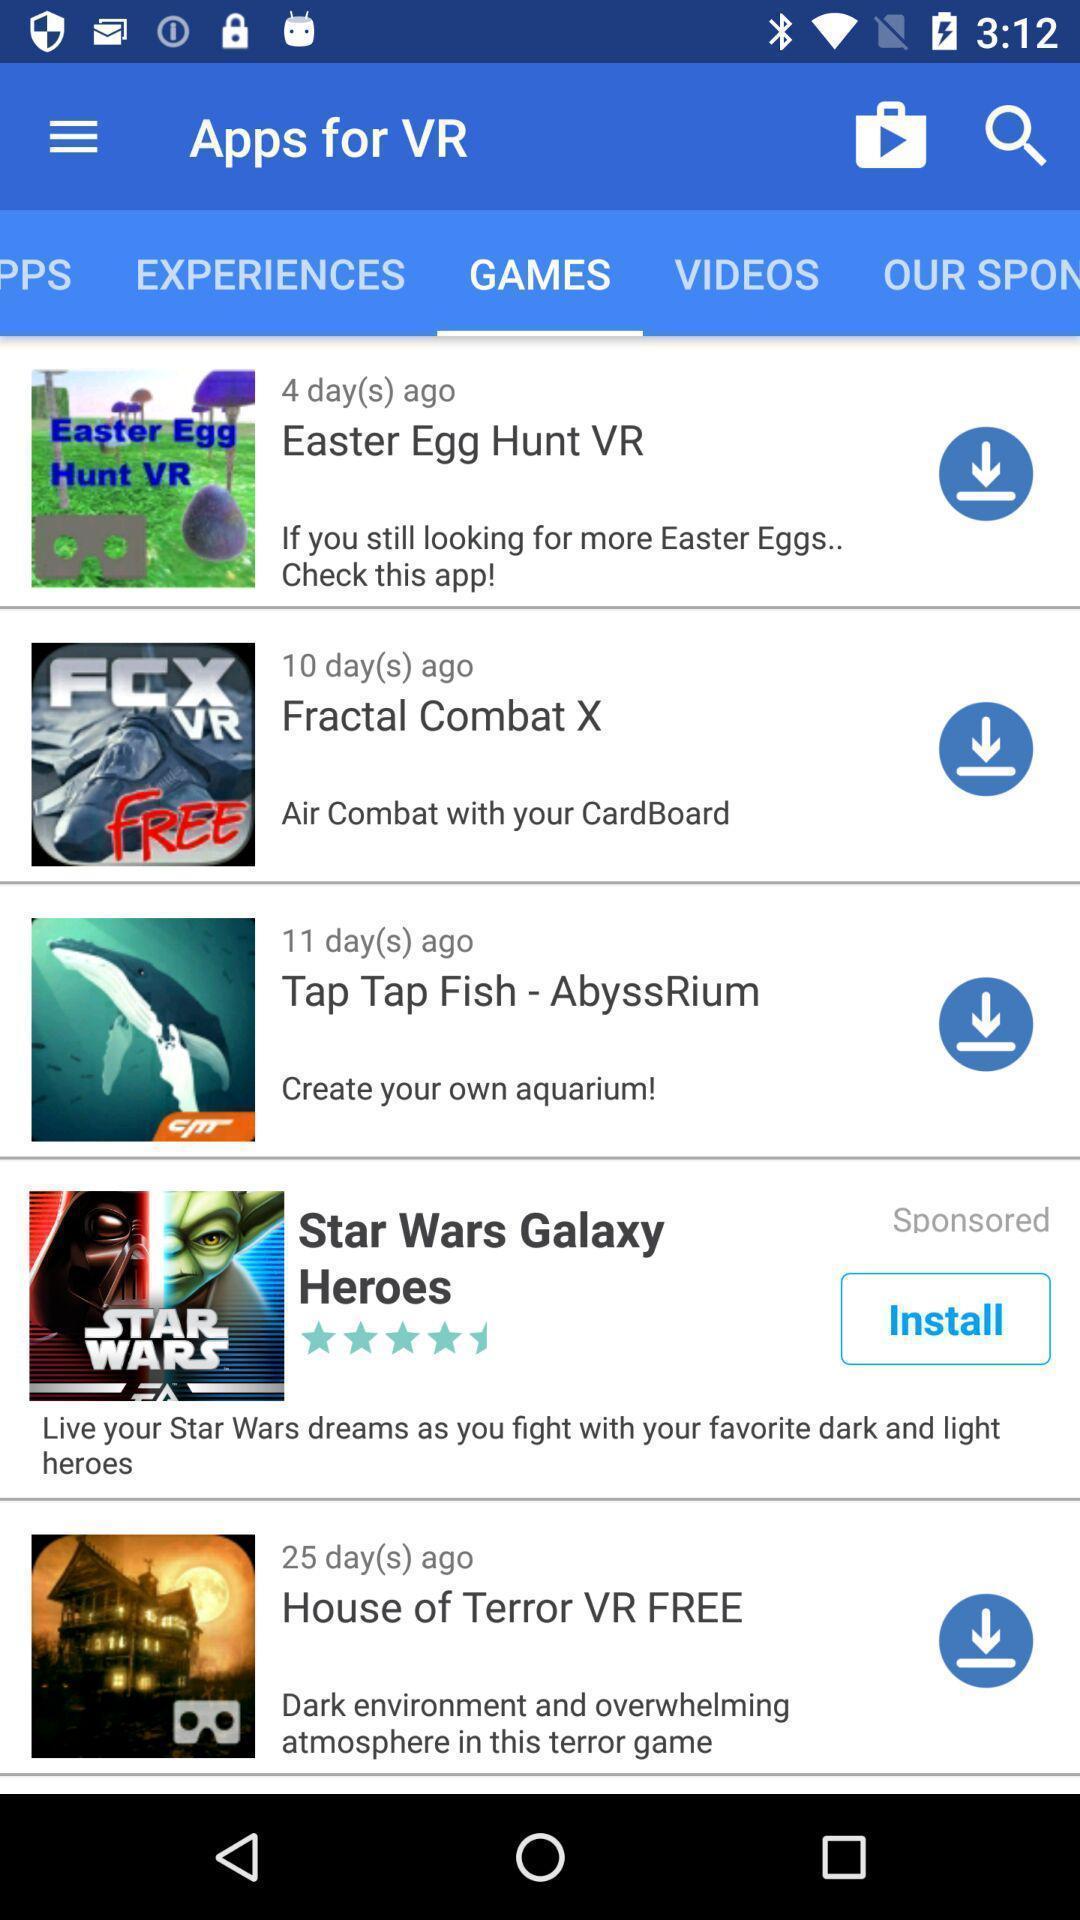What can you discern from this picture? Screen presenting the multiple games. 